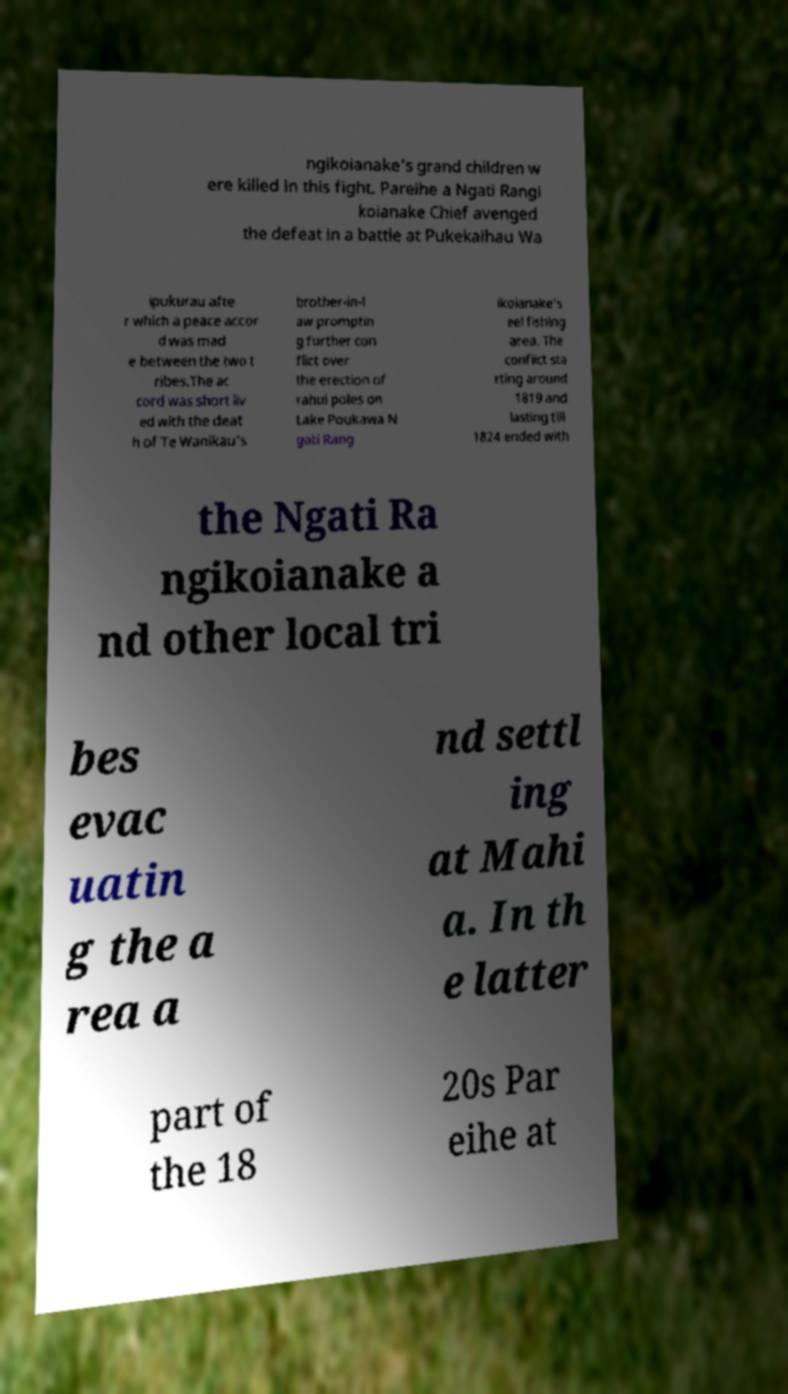There's text embedded in this image that I need extracted. Can you transcribe it verbatim? ngikoianake's grand children w ere killed in this fight. Pareihe a Ngati Rangi koianake Chief avenged the defeat in a battle at Pukekaihau Wa ipukurau afte r which a peace accor d was mad e between the two t ribes.The ac cord was short liv ed with the deat h of Te Wanikau's brother-in-l aw promptin g further con flict over the erection of rahui poles on Lake Poukawa N gati Rang ikoianake's eel fishing area. The conflict sta rting around 1819 and lasting till 1824 ended with the Ngati Ra ngikoianake a nd other local tri bes evac uatin g the a rea a nd settl ing at Mahi a. In th e latter part of the 18 20s Par eihe at 